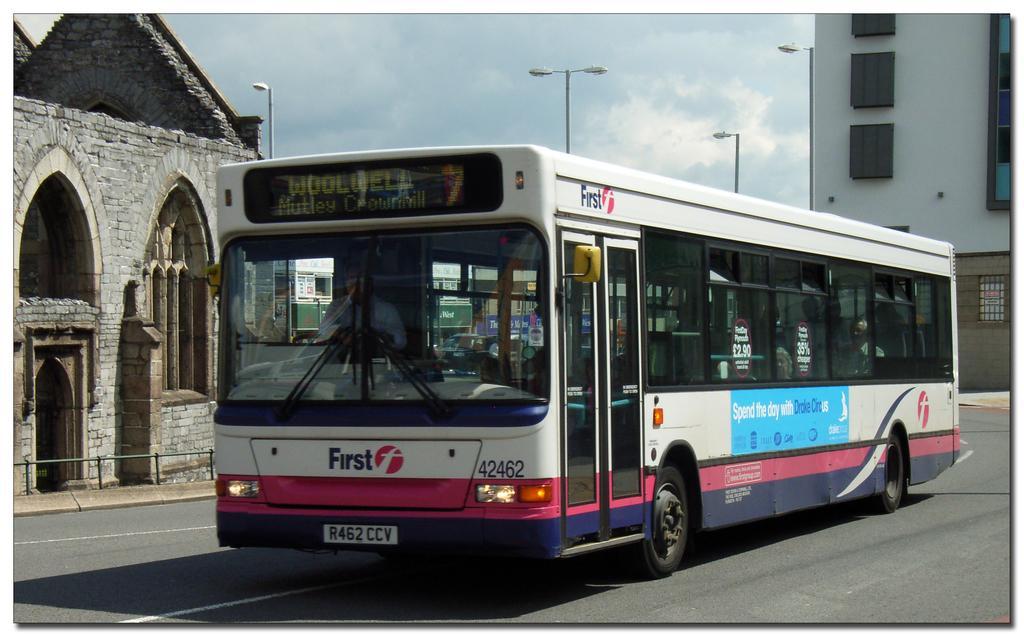How would you summarize this image in a sentence or two? In this picture we can see bus is moving on the road, around we can see few buildings. 